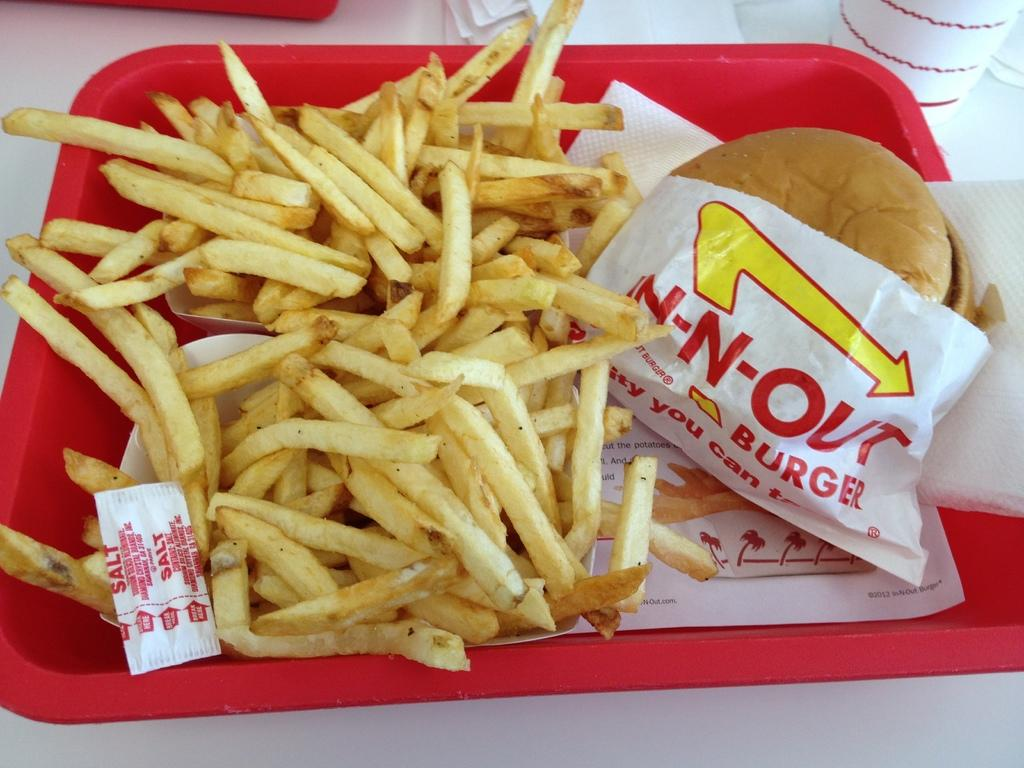What type of food can be seen in the image? There are fries and a burger in the image. What might be used for cleaning or wiping in the image? Napkins are present in the image for cleaning or wiping. What items are on the tray in the image? There are fries, a burger, salt sachets, and napkins on the tray in the image. Where is the tray located in the image? The tray is on a table in the image. What is beside the tray on the table? There is a cup and additional napkins beside the tray on the table. What is on the other tray beside the cup and napkins? There is another tray beside the cup and napkins, but the facts do not specify what is on it. What thought is expressed by the fries in the image? The fries do not express any thoughts in the image, as they are inanimate objects. 